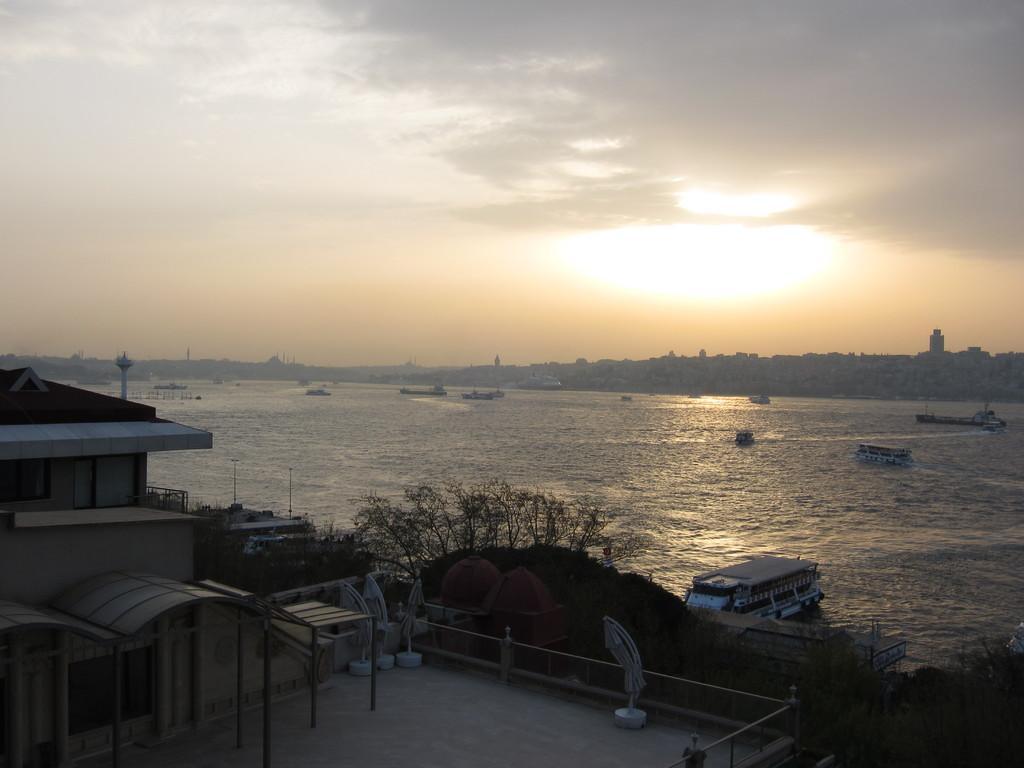Could you give a brief overview of what you see in this image? On the left side of the image we can see a shed and there are trees. In the background there is a river and there are boats in the river. We can see buildings. At the top there is sky. 